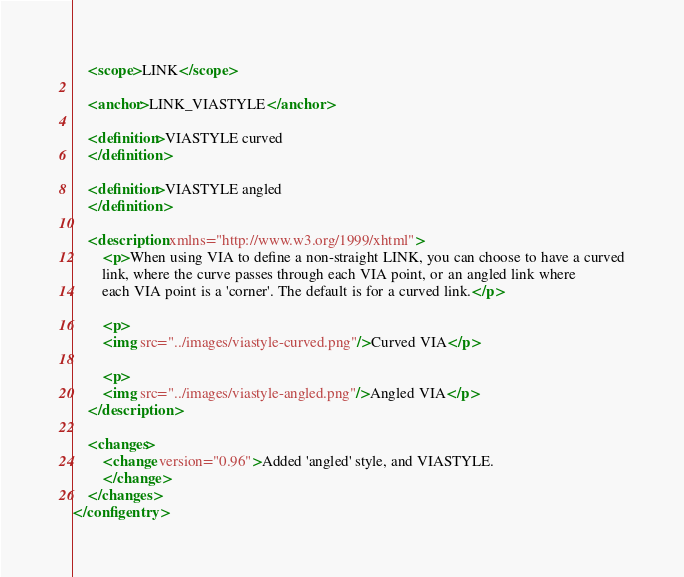<code> <loc_0><loc_0><loc_500><loc_500><_XML_>    <scope>LINK</scope>

    <anchor>LINK_VIASTYLE</anchor>

    <definition>VIASTYLE curved
    </definition>

    <definition>VIASTYLE angled
    </definition>

    <description xmlns="http://www.w3.org/1999/xhtml">
        <p>When using VIA to define a non-straight LINK, you can choose to have a curved
        link, where the curve passes through each VIA point, or an angled link where
        each VIA point is a 'corner'. The default is for a curved link.</p>

        <p>
        <img src="../images/viastyle-curved.png"/>Curved VIA</p>

        <p>
        <img src="../images/viastyle-angled.png"/>Angled VIA</p>
    </description>

    <changes>
        <change version="0.96">Added 'angled' style, and VIASTYLE.
        </change>
    </changes>
</configentry></code> 